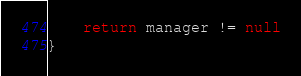Convert code to text. <code><loc_0><loc_0><loc_500><loc_500><_Kotlin_>    return manager != null
}</code> 